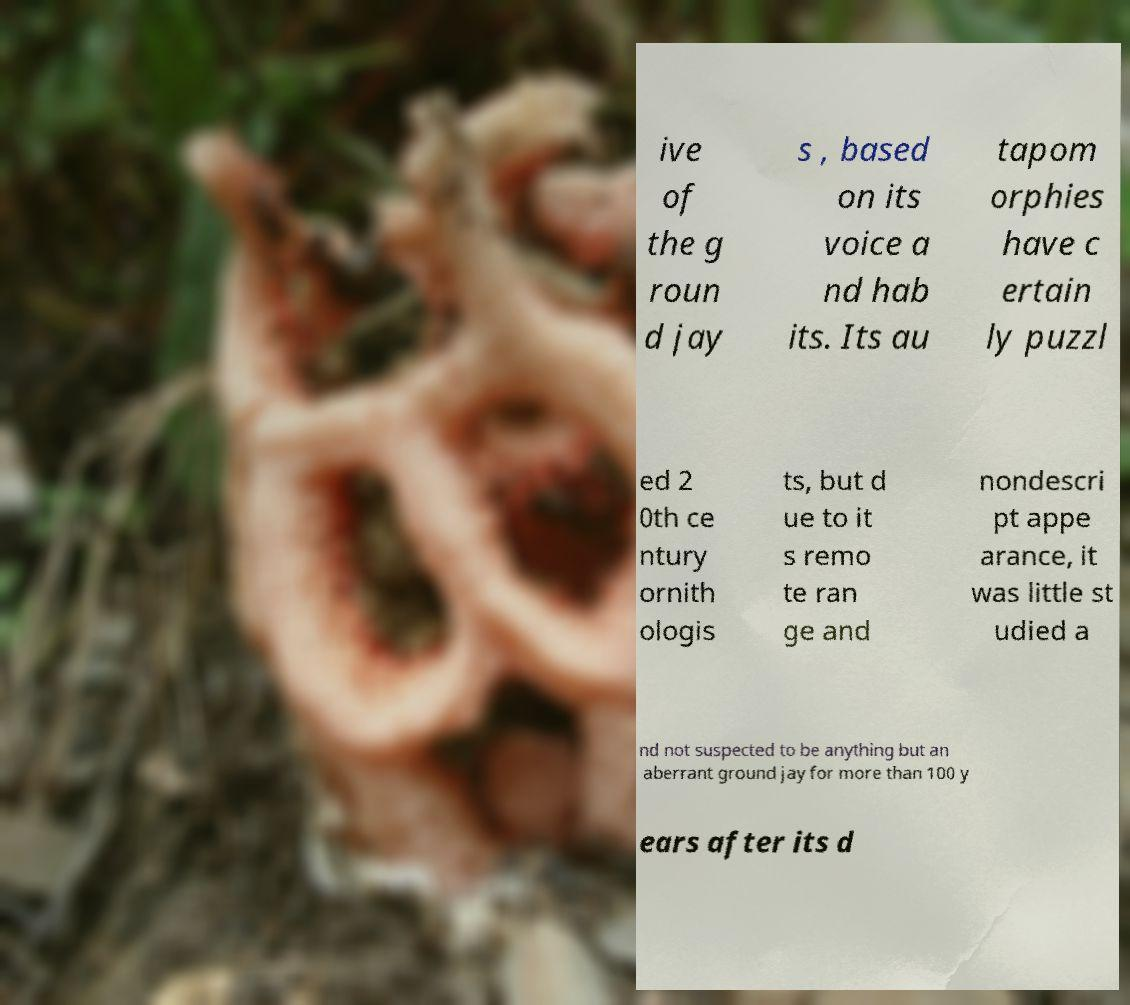Can you read and provide the text displayed in the image?This photo seems to have some interesting text. Can you extract and type it out for me? ive of the g roun d jay s , based on its voice a nd hab its. Its au tapom orphies have c ertain ly puzzl ed 2 0th ce ntury ornith ologis ts, but d ue to it s remo te ran ge and nondescri pt appe arance, it was little st udied a nd not suspected to be anything but an aberrant ground jay for more than 100 y ears after its d 